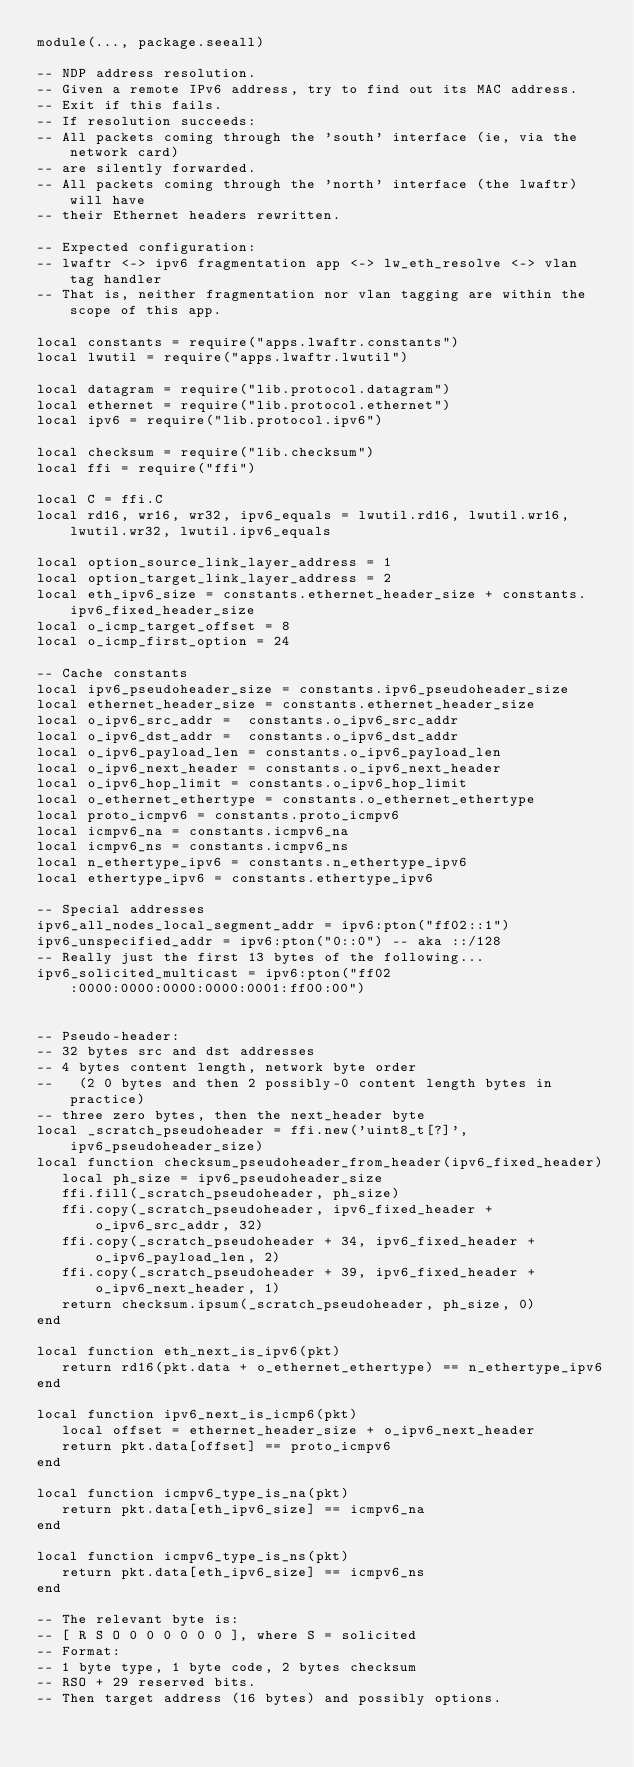<code> <loc_0><loc_0><loc_500><loc_500><_Lua_>module(..., package.seeall)

-- NDP address resolution.
-- Given a remote IPv6 address, try to find out its MAC address.
-- Exit if this fails.
-- If resolution succeeds:
-- All packets coming through the 'south' interface (ie, via the network card)
-- are silently forwarded.
-- All packets coming through the 'north' interface (the lwaftr) will have
-- their Ethernet headers rewritten.

-- Expected configuration:
-- lwaftr <-> ipv6 fragmentation app <-> lw_eth_resolve <-> vlan tag handler
-- That is, neither fragmentation nor vlan tagging are within the scope of this app.

local constants = require("apps.lwaftr.constants")
local lwutil = require("apps.lwaftr.lwutil")

local datagram = require("lib.protocol.datagram")
local ethernet = require("lib.protocol.ethernet")
local ipv6 = require("lib.protocol.ipv6")

local checksum = require("lib.checksum")
local ffi = require("ffi")

local C = ffi.C
local rd16, wr16, wr32, ipv6_equals = lwutil.rd16, lwutil.wr16, lwutil.wr32, lwutil.ipv6_equals

local option_source_link_layer_address = 1
local option_target_link_layer_address = 2
local eth_ipv6_size = constants.ethernet_header_size + constants.ipv6_fixed_header_size
local o_icmp_target_offset = 8
local o_icmp_first_option = 24

-- Cache constants
local ipv6_pseudoheader_size = constants.ipv6_pseudoheader_size
local ethernet_header_size = constants.ethernet_header_size
local o_ipv6_src_addr =  constants.o_ipv6_src_addr
local o_ipv6_dst_addr =  constants.o_ipv6_dst_addr
local o_ipv6_payload_len = constants.o_ipv6_payload_len
local o_ipv6_next_header = constants.o_ipv6_next_header
local o_ipv6_hop_limit = constants.o_ipv6_hop_limit
local o_ethernet_ethertype = constants.o_ethernet_ethertype
local proto_icmpv6 = constants.proto_icmpv6
local icmpv6_na = constants.icmpv6_na
local icmpv6_ns = constants.icmpv6_ns
local n_ethertype_ipv6 = constants.n_ethertype_ipv6
local ethertype_ipv6 = constants.ethertype_ipv6

-- Special addresses
ipv6_all_nodes_local_segment_addr = ipv6:pton("ff02::1")
ipv6_unspecified_addr = ipv6:pton("0::0") -- aka ::/128
-- Really just the first 13 bytes of the following...
ipv6_solicited_multicast = ipv6:pton("ff02:0000:0000:0000:0000:0001:ff00:00")


-- Pseudo-header:
-- 32 bytes src and dst addresses
-- 4 bytes content length, network byte order
--   (2 0 bytes and then 2 possibly-0 content length bytes in practice)
-- three zero bytes, then the next_header byte
local _scratch_pseudoheader = ffi.new('uint8_t[?]', ipv6_pseudoheader_size)
local function checksum_pseudoheader_from_header(ipv6_fixed_header)
   local ph_size = ipv6_pseudoheader_size
   ffi.fill(_scratch_pseudoheader, ph_size)
   ffi.copy(_scratch_pseudoheader, ipv6_fixed_header + o_ipv6_src_addr, 32)
   ffi.copy(_scratch_pseudoheader + 34, ipv6_fixed_header + o_ipv6_payload_len, 2)
   ffi.copy(_scratch_pseudoheader + 39, ipv6_fixed_header + o_ipv6_next_header, 1)
   return checksum.ipsum(_scratch_pseudoheader, ph_size, 0)
end

local function eth_next_is_ipv6(pkt)
   return rd16(pkt.data + o_ethernet_ethertype) == n_ethertype_ipv6
end

local function ipv6_next_is_icmp6(pkt)
   local offset = ethernet_header_size + o_ipv6_next_header
   return pkt.data[offset] == proto_icmpv6
end

local function icmpv6_type_is_na(pkt)
   return pkt.data[eth_ipv6_size] == icmpv6_na
end

local function icmpv6_type_is_ns(pkt)
   return pkt.data[eth_ipv6_size] == icmpv6_ns
end

-- The relevant byte is:
-- [ R S O 0 0 0 0 0 0 ], where S = solicited
-- Format:
-- 1 byte type, 1 byte code, 2 bytes checksum
-- RSO + 29 reserved bits.
-- Then target address (16 bytes) and possibly options.</code> 